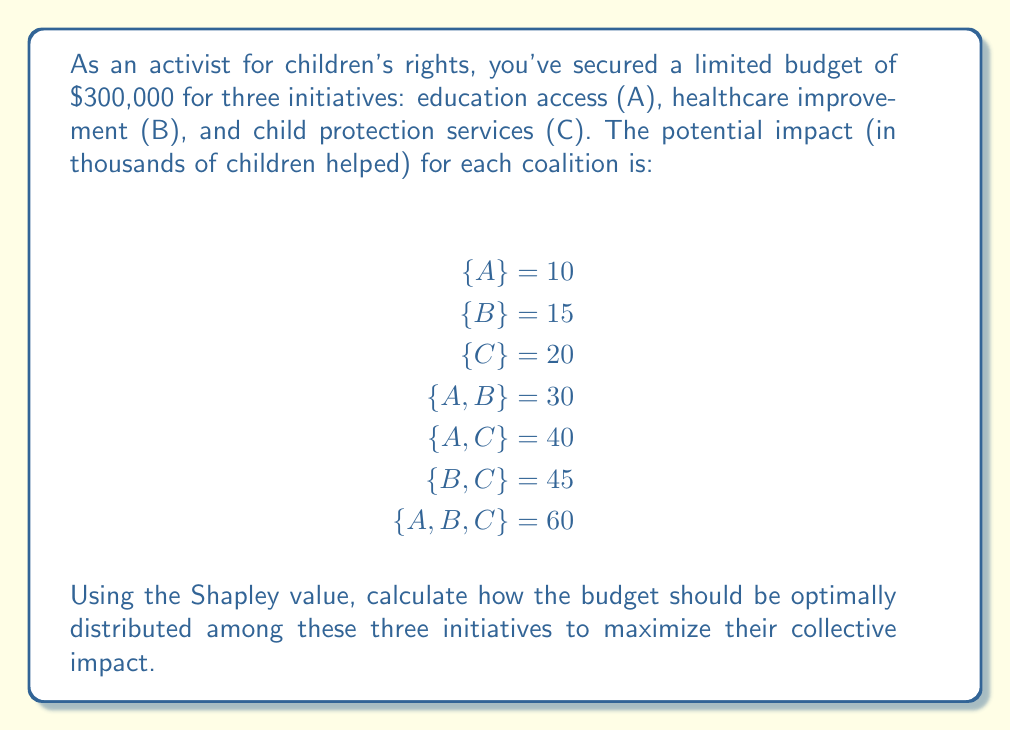Teach me how to tackle this problem. To solve this problem using the Shapley value, we need to follow these steps:

1. List all possible coalitions and their marginal contributions.
2. Calculate the Shapley value for each initiative.

Step 1: List coalitions and marginal contributions

For initiative A:
- A joins {} : 10
- A joins {B} : 30 - 15 = 15
- A joins {C} : 40 - 20 = 20
- A joins {B,C} : 60 - 45 = 15

For initiative B:
- B joins {} : 15
- B joins {A} : 30 - 10 = 20
- B joins {C} : 45 - 20 = 25
- B joins {A,C} : 60 - 40 = 20

For initiative C:
- C joins {} : 20
- C joins {A} : 40 - 10 = 30
- C joins {B} : 45 - 15 = 30
- C joins {A,B} : 60 - 30 = 30

Step 2: Calculate Shapley values

The Shapley value formula is:

$$ \phi_i(v) = \frac{1}{n!} \sum_{S \subseteq N \setminus \{i\}} |S|!(n-|S|-1)![v(S \cup \{i\}) - v(S)] $$

Where $n$ is the number of players (initiatives in this case).

For initiative A:
$$ \phi_A = \frac{1}{6}(10 + 15 + 20 + 15) = 15 $$

For initiative B:
$$ \phi_B = \frac{1}{6}(15 + 20 + 25 + 20) = 20 $$

For initiative C:
$$ \phi_C = \frac{1}{6}(20 + 30 + 30 + 30) = 25 $$

Step 3: Normalize the values

Total Shapley value: $15 + 20 + 25 = 60$

Normalized values:
A: $\frac{15}{60} = 0.25$
B: $\frac{20}{60} = 0.33333$
C: $\frac{25}{60} = 0.41667$

Step 4: Distribute the budget

A: $300,000 \times 0.25 = 75,000$
B: $300,000 \times 0.33333 = 100,000$
C: $300,000 \times 0.41667 = 125,000$
Answer: The optimal distribution of the $300,000 budget using the Shapley value is:

Education access (A): $75,000
Healthcare improvement (B): $100,000
Child protection services (C): $125,000 